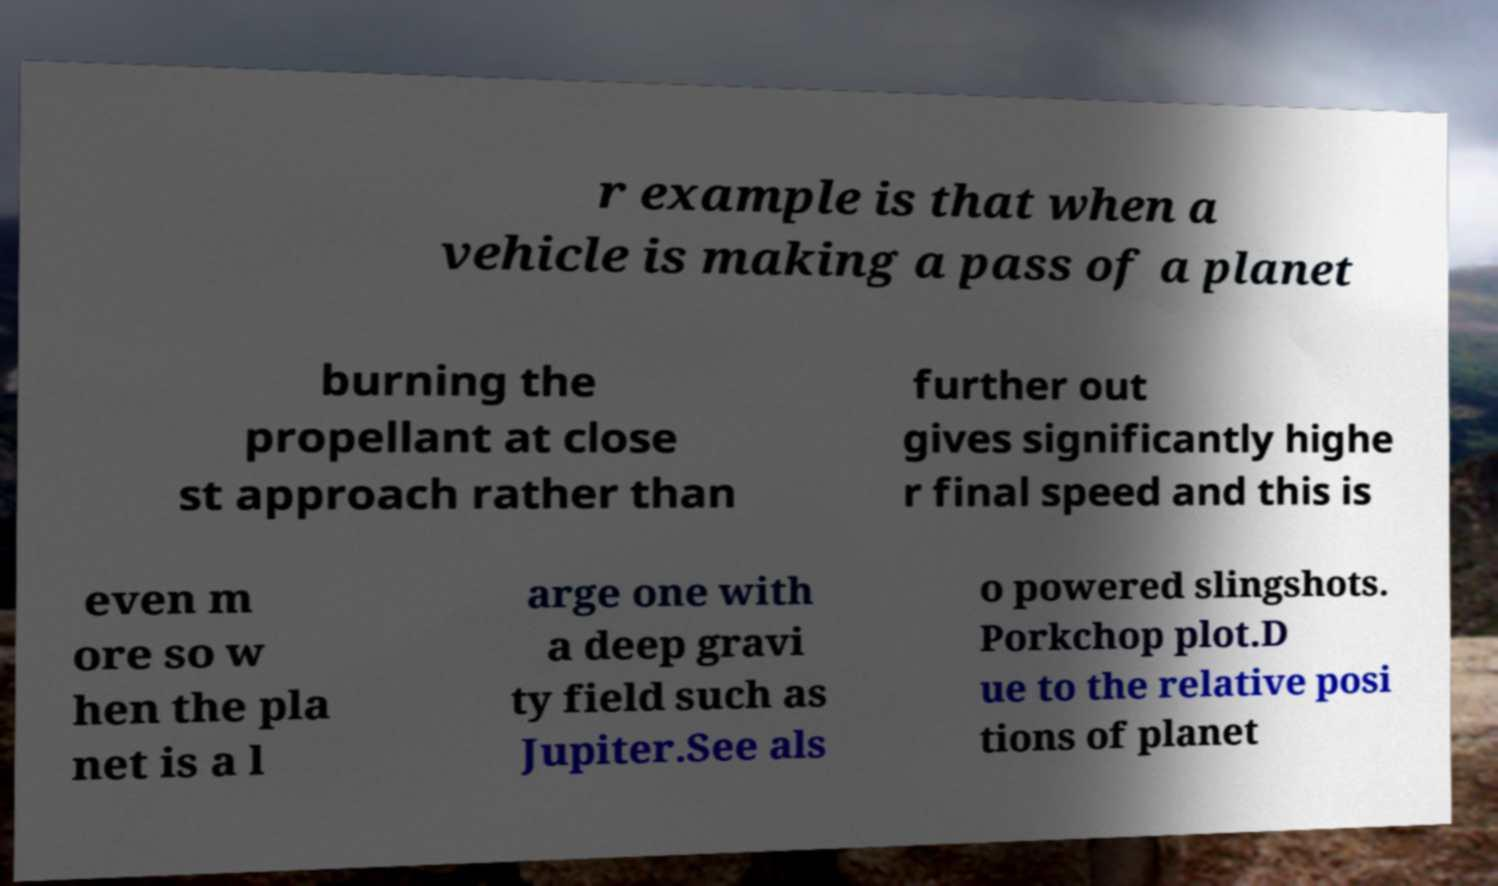For documentation purposes, I need the text within this image transcribed. Could you provide that? r example is that when a vehicle is making a pass of a planet burning the propellant at close st approach rather than further out gives significantly highe r final speed and this is even m ore so w hen the pla net is a l arge one with a deep gravi ty field such as Jupiter.See als o powered slingshots. Porkchop plot.D ue to the relative posi tions of planet 